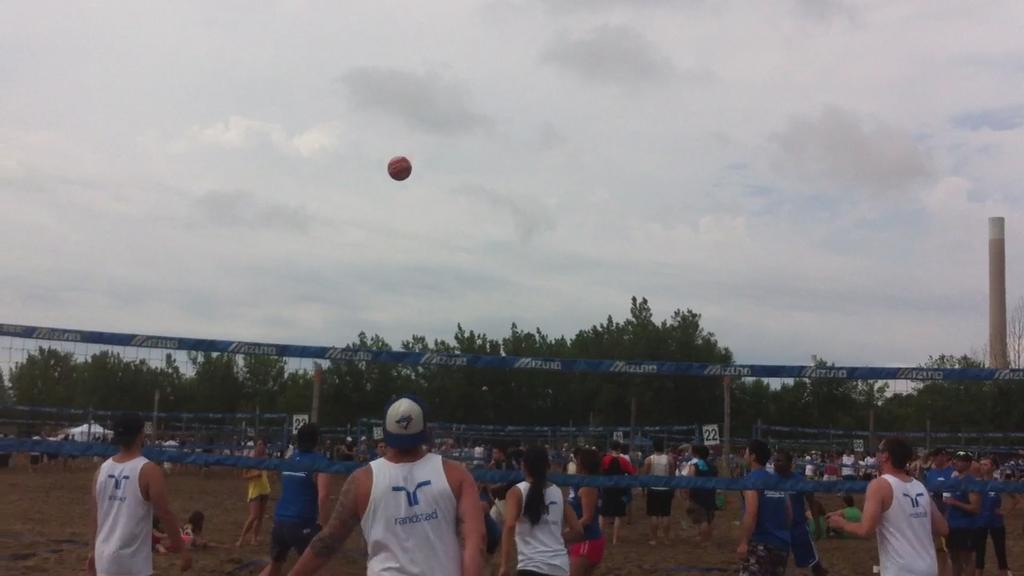What are the people in the image doing? There are players on the ground in the image, suggesting they are engaged in a game or sport. What is the main feature of the game or sport being played? There is a net in the image, which is commonly used in sports like volleyball or tennis. What object is being used by the players? There is a ball in the image, which is a common element in many sports. What can be seen in the background of the image? There are surrounding trees visible in the image, indicating that the game or sport is being played outdoors. What is the condition of the sky in the image? Clouds are present in the sky in the image, suggesting a clear or partly cloudy day. What type of process is being carried out by the voice in the image? There is no voice or process present in the image; it features players engaged in a game or sport with a net, ball, and surrounding trees. 